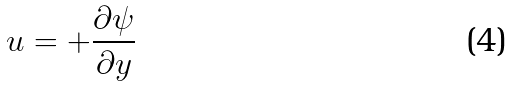<formula> <loc_0><loc_0><loc_500><loc_500>u = + \frac { \partial \psi } { \partial y }</formula> 